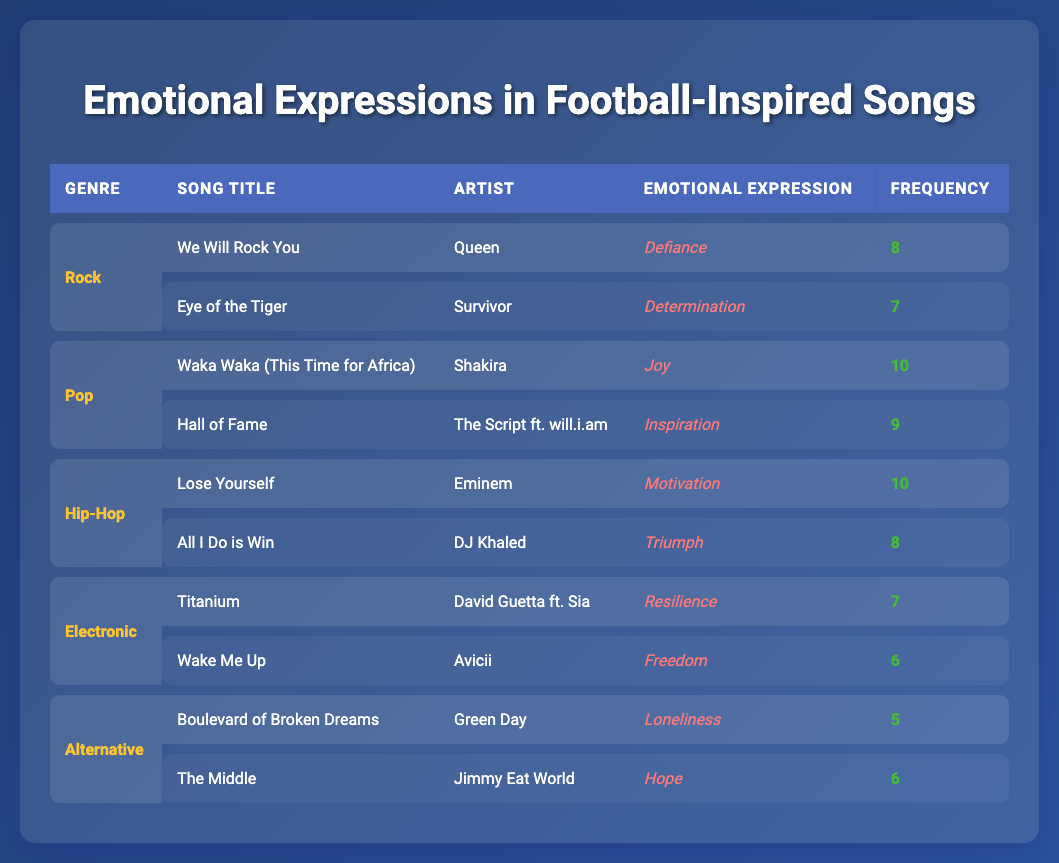What genre has the highest frequency of emotional expression in a song? Looking at the frequencies in the table, "Waka Waka (This Time for Africa)" by Shakira in the Pop genre has the highest frequency of 10.
Answer: Pop Which song by Eminem expresses the emotion of motivation? The table indicates that "Lose Yourself" is the song by Eminem that expresses the emotion of motivation.
Answer: Lose Yourself How many songs in the Rock genre are listed in the table? The table shows two songs under the Rock genre: "We Will Rock You" and "Eye of the Tiger." Thus, there are 2 songs in the Rock genre.
Answer: 2 What is the average frequency of emotional expressions in songs from the Electronic genre? The frequencies for the Electronic genre are 7 (Titanium) and 6 (Wake Me Up). The average is (7 + 6) / 2 = 6.5.
Answer: 6.5 Is there a song in the Alternative genre that expresses hope? Yes, according to the table, "The Middle" by Jimmy Eat World expresses the emotion of hope in the Alternative genre.
Answer: Yes Which genre has the lowest total frequency of emotional expressions across its songs? In the Alternative genre, the songs "Boulevard of Broken Dreams" (5) and "The Middle" (6) total 11. In contrast, Pop has a total of 19, Rock has 15, Hip-Hop has 18, and Electronic has 13. Therefore, the Alternative genre has the lowest total frequency.
Answer: Alternative What emotional expressions are most frequently associated with songs in the Hip-Hop genre? The Hip-Hop genre includes "Lose Yourself" (10 for Motivation) and "All I Do is Win" (8 for Triumph). The most frequent emotional expression in this genre is Motivation with a frequency of 10.
Answer: Motivation How many emotional expressions across all genres have a frequency of 8 or higher? By examining the table, the emotional expressions with frequencies of 8 or higher include Defiance (8), Determination (7), Joy (10), Inspiration (9), Motivation (10), and Triumph (8). Counting these gives us a total of 6 emotional expressions with frequencies of 8 or higher.
Answer: 6 What is the total frequency of emotional expressions for the Pop genre? The songs listed under Pop have frequencies of 10 (Waka Waka) and 9 (Hall of Fame). Therefore, the total frequency is 10 + 9 = 19.
Answer: 19 